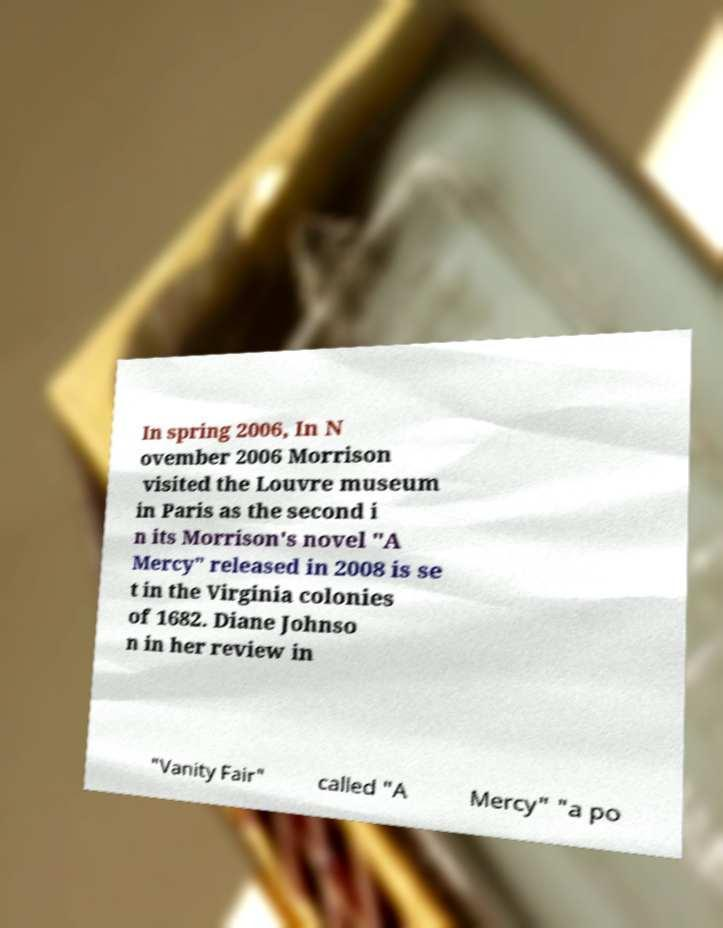Could you assist in decoding the text presented in this image and type it out clearly? In spring 2006, In N ovember 2006 Morrison visited the Louvre museum in Paris as the second i n its Morrison's novel "A Mercy" released in 2008 is se t in the Virginia colonies of 1682. Diane Johnso n in her review in "Vanity Fair" called "A Mercy" "a po 